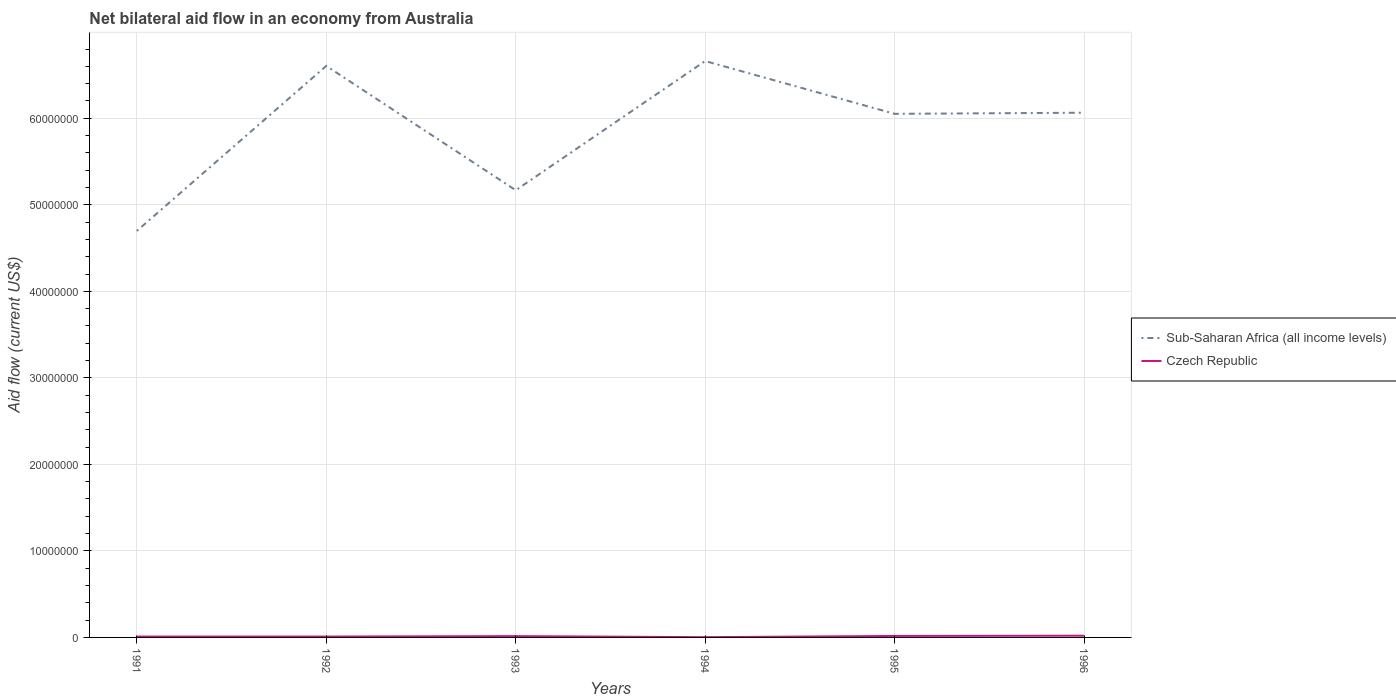Does the line corresponding to Sub-Saharan Africa (all income levels) intersect with the line corresponding to Czech Republic?
Keep it short and to the point. No. Is the number of lines equal to the number of legend labels?
Your answer should be compact. Yes. Across all years, what is the maximum net bilateral aid flow in Sub-Saharan Africa (all income levels)?
Ensure brevity in your answer.  4.70e+07. In which year was the net bilateral aid flow in Sub-Saharan Africa (all income levels) maximum?
Give a very brief answer. 1991. What is the difference between the highest and the lowest net bilateral aid flow in Czech Republic?
Ensure brevity in your answer.  3. Is the net bilateral aid flow in Czech Republic strictly greater than the net bilateral aid flow in Sub-Saharan Africa (all income levels) over the years?
Your response must be concise. Yes. Does the graph contain any zero values?
Your response must be concise. No. Does the graph contain grids?
Your response must be concise. Yes. Where does the legend appear in the graph?
Ensure brevity in your answer.  Center right. What is the title of the graph?
Offer a terse response. Net bilateral aid flow in an economy from Australia. Does "Malta" appear as one of the legend labels in the graph?
Provide a short and direct response. No. What is the label or title of the X-axis?
Your answer should be very brief. Years. What is the label or title of the Y-axis?
Keep it short and to the point. Aid flow (current US$). What is the Aid flow (current US$) in Sub-Saharan Africa (all income levels) in 1991?
Offer a very short reply. 4.70e+07. What is the Aid flow (current US$) in Czech Republic in 1991?
Keep it short and to the point. 1.00e+05. What is the Aid flow (current US$) of Sub-Saharan Africa (all income levels) in 1992?
Make the answer very short. 6.60e+07. What is the Aid flow (current US$) of Sub-Saharan Africa (all income levels) in 1993?
Make the answer very short. 5.17e+07. What is the Aid flow (current US$) in Sub-Saharan Africa (all income levels) in 1994?
Ensure brevity in your answer.  6.66e+07. What is the Aid flow (current US$) in Sub-Saharan Africa (all income levels) in 1995?
Offer a terse response. 6.05e+07. What is the Aid flow (current US$) in Sub-Saharan Africa (all income levels) in 1996?
Make the answer very short. 6.06e+07. Across all years, what is the maximum Aid flow (current US$) of Sub-Saharan Africa (all income levels)?
Provide a succinct answer. 6.66e+07. Across all years, what is the maximum Aid flow (current US$) of Czech Republic?
Make the answer very short. 2.00e+05. Across all years, what is the minimum Aid flow (current US$) in Sub-Saharan Africa (all income levels)?
Your answer should be compact. 4.70e+07. What is the total Aid flow (current US$) in Sub-Saharan Africa (all income levels) in the graph?
Provide a succinct answer. 3.52e+08. What is the total Aid flow (current US$) of Czech Republic in the graph?
Your response must be concise. 7.50e+05. What is the difference between the Aid flow (current US$) in Sub-Saharan Africa (all income levels) in 1991 and that in 1992?
Ensure brevity in your answer.  -1.91e+07. What is the difference between the Aid flow (current US$) of Sub-Saharan Africa (all income levels) in 1991 and that in 1993?
Provide a succinct answer. -4.70e+06. What is the difference between the Aid flow (current US$) of Sub-Saharan Africa (all income levels) in 1991 and that in 1994?
Provide a short and direct response. -1.96e+07. What is the difference between the Aid flow (current US$) in Sub-Saharan Africa (all income levels) in 1991 and that in 1995?
Your answer should be compact. -1.35e+07. What is the difference between the Aid flow (current US$) of Sub-Saharan Africa (all income levels) in 1991 and that in 1996?
Your response must be concise. -1.37e+07. What is the difference between the Aid flow (current US$) of Czech Republic in 1991 and that in 1996?
Provide a short and direct response. -1.00e+05. What is the difference between the Aid flow (current US$) in Sub-Saharan Africa (all income levels) in 1992 and that in 1993?
Your answer should be compact. 1.44e+07. What is the difference between the Aid flow (current US$) in Czech Republic in 1992 and that in 1993?
Ensure brevity in your answer.  -5.00e+04. What is the difference between the Aid flow (current US$) in Sub-Saharan Africa (all income levels) in 1992 and that in 1994?
Your answer should be compact. -5.60e+05. What is the difference between the Aid flow (current US$) in Sub-Saharan Africa (all income levels) in 1992 and that in 1995?
Keep it short and to the point. 5.54e+06. What is the difference between the Aid flow (current US$) in Czech Republic in 1992 and that in 1995?
Make the answer very short. -7.00e+04. What is the difference between the Aid flow (current US$) of Sub-Saharan Africa (all income levels) in 1992 and that in 1996?
Your response must be concise. 5.41e+06. What is the difference between the Aid flow (current US$) in Czech Republic in 1992 and that in 1996?
Your answer should be very brief. -1.00e+05. What is the difference between the Aid flow (current US$) of Sub-Saharan Africa (all income levels) in 1993 and that in 1994?
Provide a succinct answer. -1.49e+07. What is the difference between the Aid flow (current US$) in Czech Republic in 1993 and that in 1994?
Ensure brevity in your answer.  1.20e+05. What is the difference between the Aid flow (current US$) of Sub-Saharan Africa (all income levels) in 1993 and that in 1995?
Give a very brief answer. -8.83e+06. What is the difference between the Aid flow (current US$) in Czech Republic in 1993 and that in 1995?
Your answer should be compact. -2.00e+04. What is the difference between the Aid flow (current US$) in Sub-Saharan Africa (all income levels) in 1993 and that in 1996?
Give a very brief answer. -8.96e+06. What is the difference between the Aid flow (current US$) in Sub-Saharan Africa (all income levels) in 1994 and that in 1995?
Your answer should be compact. 6.10e+06. What is the difference between the Aid flow (current US$) in Sub-Saharan Africa (all income levels) in 1994 and that in 1996?
Give a very brief answer. 5.97e+06. What is the difference between the Aid flow (current US$) in Czech Republic in 1994 and that in 1996?
Offer a very short reply. -1.70e+05. What is the difference between the Aid flow (current US$) in Czech Republic in 1995 and that in 1996?
Provide a short and direct response. -3.00e+04. What is the difference between the Aid flow (current US$) of Sub-Saharan Africa (all income levels) in 1991 and the Aid flow (current US$) of Czech Republic in 1992?
Provide a short and direct response. 4.69e+07. What is the difference between the Aid flow (current US$) of Sub-Saharan Africa (all income levels) in 1991 and the Aid flow (current US$) of Czech Republic in 1993?
Offer a terse response. 4.68e+07. What is the difference between the Aid flow (current US$) in Sub-Saharan Africa (all income levels) in 1991 and the Aid flow (current US$) in Czech Republic in 1994?
Your answer should be compact. 4.70e+07. What is the difference between the Aid flow (current US$) of Sub-Saharan Africa (all income levels) in 1991 and the Aid flow (current US$) of Czech Republic in 1995?
Your response must be concise. 4.68e+07. What is the difference between the Aid flow (current US$) of Sub-Saharan Africa (all income levels) in 1991 and the Aid flow (current US$) of Czech Republic in 1996?
Your answer should be compact. 4.68e+07. What is the difference between the Aid flow (current US$) in Sub-Saharan Africa (all income levels) in 1992 and the Aid flow (current US$) in Czech Republic in 1993?
Offer a very short reply. 6.59e+07. What is the difference between the Aid flow (current US$) in Sub-Saharan Africa (all income levels) in 1992 and the Aid flow (current US$) in Czech Republic in 1994?
Provide a short and direct response. 6.60e+07. What is the difference between the Aid flow (current US$) in Sub-Saharan Africa (all income levels) in 1992 and the Aid flow (current US$) in Czech Republic in 1995?
Provide a succinct answer. 6.59e+07. What is the difference between the Aid flow (current US$) of Sub-Saharan Africa (all income levels) in 1992 and the Aid flow (current US$) of Czech Republic in 1996?
Offer a very short reply. 6.58e+07. What is the difference between the Aid flow (current US$) in Sub-Saharan Africa (all income levels) in 1993 and the Aid flow (current US$) in Czech Republic in 1994?
Offer a terse response. 5.16e+07. What is the difference between the Aid flow (current US$) of Sub-Saharan Africa (all income levels) in 1993 and the Aid flow (current US$) of Czech Republic in 1995?
Your answer should be very brief. 5.15e+07. What is the difference between the Aid flow (current US$) in Sub-Saharan Africa (all income levels) in 1993 and the Aid flow (current US$) in Czech Republic in 1996?
Make the answer very short. 5.15e+07. What is the difference between the Aid flow (current US$) in Sub-Saharan Africa (all income levels) in 1994 and the Aid flow (current US$) in Czech Republic in 1995?
Provide a short and direct response. 6.64e+07. What is the difference between the Aid flow (current US$) in Sub-Saharan Africa (all income levels) in 1994 and the Aid flow (current US$) in Czech Republic in 1996?
Provide a short and direct response. 6.64e+07. What is the difference between the Aid flow (current US$) in Sub-Saharan Africa (all income levels) in 1995 and the Aid flow (current US$) in Czech Republic in 1996?
Ensure brevity in your answer.  6.03e+07. What is the average Aid flow (current US$) of Sub-Saharan Africa (all income levels) per year?
Provide a short and direct response. 5.87e+07. What is the average Aid flow (current US$) in Czech Republic per year?
Ensure brevity in your answer.  1.25e+05. In the year 1991, what is the difference between the Aid flow (current US$) of Sub-Saharan Africa (all income levels) and Aid flow (current US$) of Czech Republic?
Offer a terse response. 4.69e+07. In the year 1992, what is the difference between the Aid flow (current US$) of Sub-Saharan Africa (all income levels) and Aid flow (current US$) of Czech Republic?
Your response must be concise. 6.60e+07. In the year 1993, what is the difference between the Aid flow (current US$) of Sub-Saharan Africa (all income levels) and Aid flow (current US$) of Czech Republic?
Your answer should be compact. 5.15e+07. In the year 1994, what is the difference between the Aid flow (current US$) of Sub-Saharan Africa (all income levels) and Aid flow (current US$) of Czech Republic?
Provide a succinct answer. 6.66e+07. In the year 1995, what is the difference between the Aid flow (current US$) in Sub-Saharan Africa (all income levels) and Aid flow (current US$) in Czech Republic?
Your response must be concise. 6.03e+07. In the year 1996, what is the difference between the Aid flow (current US$) in Sub-Saharan Africa (all income levels) and Aid flow (current US$) in Czech Republic?
Give a very brief answer. 6.04e+07. What is the ratio of the Aid flow (current US$) in Sub-Saharan Africa (all income levels) in 1991 to that in 1992?
Your response must be concise. 0.71. What is the ratio of the Aid flow (current US$) of Sub-Saharan Africa (all income levels) in 1991 to that in 1993?
Keep it short and to the point. 0.91. What is the ratio of the Aid flow (current US$) of Sub-Saharan Africa (all income levels) in 1991 to that in 1994?
Ensure brevity in your answer.  0.71. What is the ratio of the Aid flow (current US$) in Czech Republic in 1991 to that in 1994?
Offer a terse response. 3.33. What is the ratio of the Aid flow (current US$) of Sub-Saharan Africa (all income levels) in 1991 to that in 1995?
Ensure brevity in your answer.  0.78. What is the ratio of the Aid flow (current US$) in Czech Republic in 1991 to that in 1995?
Give a very brief answer. 0.59. What is the ratio of the Aid flow (current US$) in Sub-Saharan Africa (all income levels) in 1991 to that in 1996?
Ensure brevity in your answer.  0.77. What is the ratio of the Aid flow (current US$) in Czech Republic in 1991 to that in 1996?
Provide a short and direct response. 0.5. What is the ratio of the Aid flow (current US$) in Sub-Saharan Africa (all income levels) in 1992 to that in 1993?
Make the answer very short. 1.28. What is the ratio of the Aid flow (current US$) in Czech Republic in 1992 to that in 1993?
Provide a succinct answer. 0.67. What is the ratio of the Aid flow (current US$) of Sub-Saharan Africa (all income levels) in 1992 to that in 1995?
Give a very brief answer. 1.09. What is the ratio of the Aid flow (current US$) of Czech Republic in 1992 to that in 1995?
Provide a short and direct response. 0.59. What is the ratio of the Aid flow (current US$) of Sub-Saharan Africa (all income levels) in 1992 to that in 1996?
Ensure brevity in your answer.  1.09. What is the ratio of the Aid flow (current US$) in Czech Republic in 1992 to that in 1996?
Your answer should be compact. 0.5. What is the ratio of the Aid flow (current US$) of Sub-Saharan Africa (all income levels) in 1993 to that in 1994?
Your answer should be compact. 0.78. What is the ratio of the Aid flow (current US$) in Czech Republic in 1993 to that in 1994?
Your response must be concise. 5. What is the ratio of the Aid flow (current US$) in Sub-Saharan Africa (all income levels) in 1993 to that in 1995?
Keep it short and to the point. 0.85. What is the ratio of the Aid flow (current US$) of Czech Republic in 1993 to that in 1995?
Your answer should be very brief. 0.88. What is the ratio of the Aid flow (current US$) in Sub-Saharan Africa (all income levels) in 1993 to that in 1996?
Offer a very short reply. 0.85. What is the ratio of the Aid flow (current US$) in Czech Republic in 1993 to that in 1996?
Offer a terse response. 0.75. What is the ratio of the Aid flow (current US$) of Sub-Saharan Africa (all income levels) in 1994 to that in 1995?
Ensure brevity in your answer.  1.1. What is the ratio of the Aid flow (current US$) in Czech Republic in 1994 to that in 1995?
Make the answer very short. 0.18. What is the ratio of the Aid flow (current US$) of Sub-Saharan Africa (all income levels) in 1994 to that in 1996?
Offer a terse response. 1.1. What is the ratio of the Aid flow (current US$) in Czech Republic in 1995 to that in 1996?
Provide a succinct answer. 0.85. What is the difference between the highest and the second highest Aid flow (current US$) in Sub-Saharan Africa (all income levels)?
Keep it short and to the point. 5.60e+05. What is the difference between the highest and the lowest Aid flow (current US$) in Sub-Saharan Africa (all income levels)?
Provide a succinct answer. 1.96e+07. What is the difference between the highest and the lowest Aid flow (current US$) in Czech Republic?
Your response must be concise. 1.70e+05. 